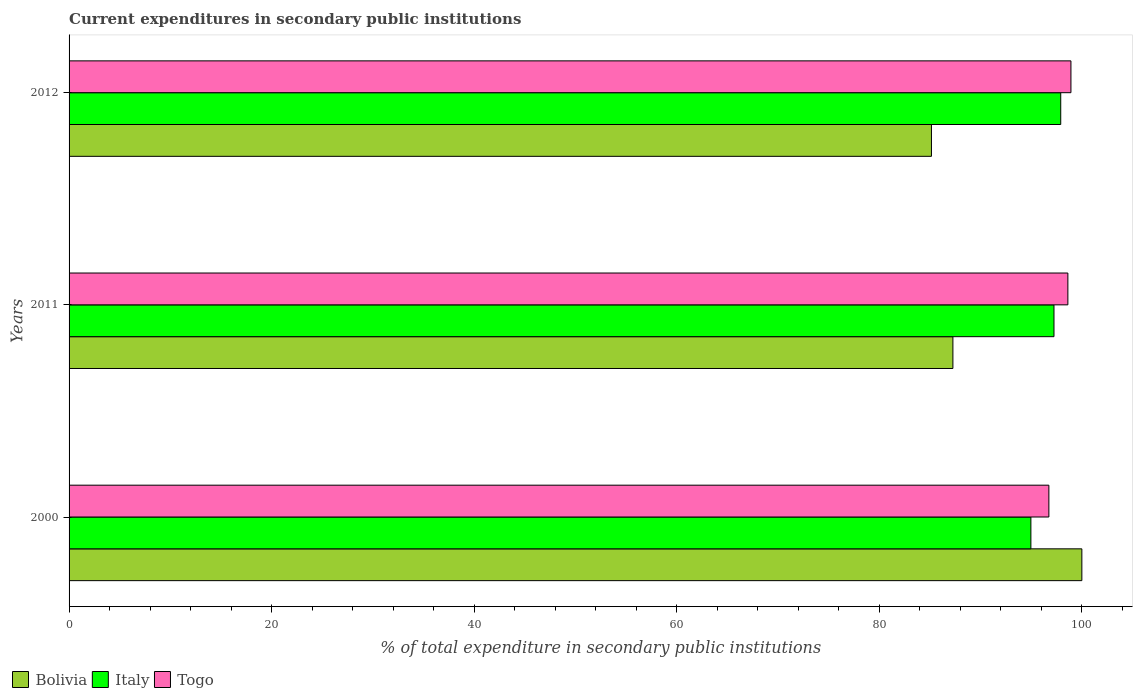How many groups of bars are there?
Offer a very short reply. 3. Are the number of bars per tick equal to the number of legend labels?
Keep it short and to the point. Yes. Are the number of bars on each tick of the Y-axis equal?
Provide a short and direct response. Yes. In how many cases, is the number of bars for a given year not equal to the number of legend labels?
Your response must be concise. 0. What is the current expenditures in secondary public institutions in Italy in 2012?
Provide a succinct answer. 97.91. Across all years, what is the maximum current expenditures in secondary public institutions in Bolivia?
Provide a short and direct response. 100. Across all years, what is the minimum current expenditures in secondary public institutions in Togo?
Give a very brief answer. 96.74. What is the total current expenditures in secondary public institutions in Italy in the graph?
Keep it short and to the point. 290.12. What is the difference between the current expenditures in secondary public institutions in Bolivia in 2011 and that in 2012?
Your answer should be very brief. 2.12. What is the difference between the current expenditures in secondary public institutions in Togo in 2011 and the current expenditures in secondary public institutions in Bolivia in 2012?
Ensure brevity in your answer.  13.47. What is the average current expenditures in secondary public institutions in Italy per year?
Make the answer very short. 96.71. In the year 2000, what is the difference between the current expenditures in secondary public institutions in Bolivia and current expenditures in secondary public institutions in Italy?
Your answer should be compact. 5.03. What is the ratio of the current expenditures in secondary public institutions in Bolivia in 2011 to that in 2012?
Ensure brevity in your answer.  1.02. Is the current expenditures in secondary public institutions in Togo in 2000 less than that in 2012?
Give a very brief answer. Yes. Is the difference between the current expenditures in secondary public institutions in Bolivia in 2011 and 2012 greater than the difference between the current expenditures in secondary public institutions in Italy in 2011 and 2012?
Offer a very short reply. Yes. What is the difference between the highest and the second highest current expenditures in secondary public institutions in Togo?
Provide a short and direct response. 0.3. What is the difference between the highest and the lowest current expenditures in secondary public institutions in Bolivia?
Give a very brief answer. 14.85. What does the 3rd bar from the top in 2011 represents?
Your answer should be very brief. Bolivia. What does the 2nd bar from the bottom in 2011 represents?
Give a very brief answer. Italy. Is it the case that in every year, the sum of the current expenditures in secondary public institutions in Togo and current expenditures in secondary public institutions in Bolivia is greater than the current expenditures in secondary public institutions in Italy?
Your response must be concise. Yes. How many bars are there?
Your answer should be compact. 9. Are all the bars in the graph horizontal?
Ensure brevity in your answer.  Yes. How many years are there in the graph?
Keep it short and to the point. 3. Are the values on the major ticks of X-axis written in scientific E-notation?
Your response must be concise. No. Does the graph contain grids?
Make the answer very short. No. How many legend labels are there?
Your response must be concise. 3. What is the title of the graph?
Offer a terse response. Current expenditures in secondary public institutions. Does "Channel Islands" appear as one of the legend labels in the graph?
Give a very brief answer. No. What is the label or title of the X-axis?
Offer a very short reply. % of total expenditure in secondary public institutions. What is the label or title of the Y-axis?
Your response must be concise. Years. What is the % of total expenditure in secondary public institutions in Bolivia in 2000?
Offer a terse response. 100. What is the % of total expenditure in secondary public institutions in Italy in 2000?
Give a very brief answer. 94.97. What is the % of total expenditure in secondary public institutions of Togo in 2000?
Give a very brief answer. 96.74. What is the % of total expenditure in secondary public institutions of Bolivia in 2011?
Offer a terse response. 87.27. What is the % of total expenditure in secondary public institutions in Italy in 2011?
Offer a very short reply. 97.25. What is the % of total expenditure in secondary public institutions of Togo in 2011?
Make the answer very short. 98.62. What is the % of total expenditure in secondary public institutions in Bolivia in 2012?
Keep it short and to the point. 85.15. What is the % of total expenditure in secondary public institutions of Italy in 2012?
Your answer should be compact. 97.91. What is the % of total expenditure in secondary public institutions in Togo in 2012?
Provide a succinct answer. 98.92. Across all years, what is the maximum % of total expenditure in secondary public institutions in Bolivia?
Provide a succinct answer. 100. Across all years, what is the maximum % of total expenditure in secondary public institutions in Italy?
Make the answer very short. 97.91. Across all years, what is the maximum % of total expenditure in secondary public institutions of Togo?
Your answer should be very brief. 98.92. Across all years, what is the minimum % of total expenditure in secondary public institutions of Bolivia?
Give a very brief answer. 85.15. Across all years, what is the minimum % of total expenditure in secondary public institutions of Italy?
Your answer should be compact. 94.97. Across all years, what is the minimum % of total expenditure in secondary public institutions of Togo?
Offer a very short reply. 96.74. What is the total % of total expenditure in secondary public institutions of Bolivia in the graph?
Provide a succinct answer. 272.41. What is the total % of total expenditure in secondary public institutions in Italy in the graph?
Ensure brevity in your answer.  290.12. What is the total % of total expenditure in secondary public institutions of Togo in the graph?
Offer a very short reply. 294.28. What is the difference between the % of total expenditure in secondary public institutions in Bolivia in 2000 and that in 2011?
Your response must be concise. 12.73. What is the difference between the % of total expenditure in secondary public institutions in Italy in 2000 and that in 2011?
Offer a terse response. -2.28. What is the difference between the % of total expenditure in secondary public institutions of Togo in 2000 and that in 2011?
Offer a terse response. -1.88. What is the difference between the % of total expenditure in secondary public institutions in Bolivia in 2000 and that in 2012?
Provide a short and direct response. 14.85. What is the difference between the % of total expenditure in secondary public institutions of Italy in 2000 and that in 2012?
Offer a very short reply. -2.95. What is the difference between the % of total expenditure in secondary public institutions of Togo in 2000 and that in 2012?
Keep it short and to the point. -2.18. What is the difference between the % of total expenditure in secondary public institutions in Bolivia in 2011 and that in 2012?
Keep it short and to the point. 2.12. What is the difference between the % of total expenditure in secondary public institutions in Italy in 2011 and that in 2012?
Your answer should be compact. -0.67. What is the difference between the % of total expenditure in secondary public institutions in Togo in 2011 and that in 2012?
Offer a very short reply. -0.3. What is the difference between the % of total expenditure in secondary public institutions in Bolivia in 2000 and the % of total expenditure in secondary public institutions in Italy in 2011?
Provide a short and direct response. 2.75. What is the difference between the % of total expenditure in secondary public institutions of Bolivia in 2000 and the % of total expenditure in secondary public institutions of Togo in 2011?
Ensure brevity in your answer.  1.38. What is the difference between the % of total expenditure in secondary public institutions in Italy in 2000 and the % of total expenditure in secondary public institutions in Togo in 2011?
Offer a terse response. -3.65. What is the difference between the % of total expenditure in secondary public institutions of Bolivia in 2000 and the % of total expenditure in secondary public institutions of Italy in 2012?
Give a very brief answer. 2.08. What is the difference between the % of total expenditure in secondary public institutions in Bolivia in 2000 and the % of total expenditure in secondary public institutions in Togo in 2012?
Your answer should be compact. 1.08. What is the difference between the % of total expenditure in secondary public institutions in Italy in 2000 and the % of total expenditure in secondary public institutions in Togo in 2012?
Your answer should be compact. -3.95. What is the difference between the % of total expenditure in secondary public institutions of Bolivia in 2011 and the % of total expenditure in secondary public institutions of Italy in 2012?
Offer a very short reply. -10.65. What is the difference between the % of total expenditure in secondary public institutions in Bolivia in 2011 and the % of total expenditure in secondary public institutions in Togo in 2012?
Keep it short and to the point. -11.65. What is the difference between the % of total expenditure in secondary public institutions in Italy in 2011 and the % of total expenditure in secondary public institutions in Togo in 2012?
Your answer should be compact. -1.67. What is the average % of total expenditure in secondary public institutions in Bolivia per year?
Ensure brevity in your answer.  90.8. What is the average % of total expenditure in secondary public institutions in Italy per year?
Your answer should be very brief. 96.71. What is the average % of total expenditure in secondary public institutions of Togo per year?
Keep it short and to the point. 98.09. In the year 2000, what is the difference between the % of total expenditure in secondary public institutions of Bolivia and % of total expenditure in secondary public institutions of Italy?
Provide a succinct answer. 5.03. In the year 2000, what is the difference between the % of total expenditure in secondary public institutions in Bolivia and % of total expenditure in secondary public institutions in Togo?
Offer a terse response. 3.26. In the year 2000, what is the difference between the % of total expenditure in secondary public institutions of Italy and % of total expenditure in secondary public institutions of Togo?
Offer a terse response. -1.78. In the year 2011, what is the difference between the % of total expenditure in secondary public institutions of Bolivia and % of total expenditure in secondary public institutions of Italy?
Your response must be concise. -9.98. In the year 2011, what is the difference between the % of total expenditure in secondary public institutions of Bolivia and % of total expenditure in secondary public institutions of Togo?
Offer a terse response. -11.35. In the year 2011, what is the difference between the % of total expenditure in secondary public institutions in Italy and % of total expenditure in secondary public institutions in Togo?
Ensure brevity in your answer.  -1.37. In the year 2012, what is the difference between the % of total expenditure in secondary public institutions in Bolivia and % of total expenditure in secondary public institutions in Italy?
Give a very brief answer. -12.77. In the year 2012, what is the difference between the % of total expenditure in secondary public institutions in Bolivia and % of total expenditure in secondary public institutions in Togo?
Your response must be concise. -13.77. In the year 2012, what is the difference between the % of total expenditure in secondary public institutions of Italy and % of total expenditure in secondary public institutions of Togo?
Make the answer very short. -1.01. What is the ratio of the % of total expenditure in secondary public institutions of Bolivia in 2000 to that in 2011?
Offer a very short reply. 1.15. What is the ratio of the % of total expenditure in secondary public institutions in Italy in 2000 to that in 2011?
Make the answer very short. 0.98. What is the ratio of the % of total expenditure in secondary public institutions in Bolivia in 2000 to that in 2012?
Your answer should be very brief. 1.17. What is the ratio of the % of total expenditure in secondary public institutions in Italy in 2000 to that in 2012?
Make the answer very short. 0.97. What is the ratio of the % of total expenditure in secondary public institutions of Bolivia in 2011 to that in 2012?
Keep it short and to the point. 1.02. What is the ratio of the % of total expenditure in secondary public institutions in Togo in 2011 to that in 2012?
Offer a very short reply. 1. What is the difference between the highest and the second highest % of total expenditure in secondary public institutions of Bolivia?
Provide a short and direct response. 12.73. What is the difference between the highest and the second highest % of total expenditure in secondary public institutions of Italy?
Your answer should be compact. 0.67. What is the difference between the highest and the second highest % of total expenditure in secondary public institutions in Togo?
Your answer should be very brief. 0.3. What is the difference between the highest and the lowest % of total expenditure in secondary public institutions of Bolivia?
Provide a succinct answer. 14.85. What is the difference between the highest and the lowest % of total expenditure in secondary public institutions of Italy?
Keep it short and to the point. 2.95. What is the difference between the highest and the lowest % of total expenditure in secondary public institutions in Togo?
Your answer should be compact. 2.18. 